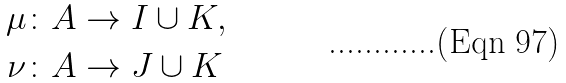Convert formula to latex. <formula><loc_0><loc_0><loc_500><loc_500>\mu & \colon A \rightarrow I \cup K , \\ \nu & \colon A \rightarrow J \cup K</formula> 